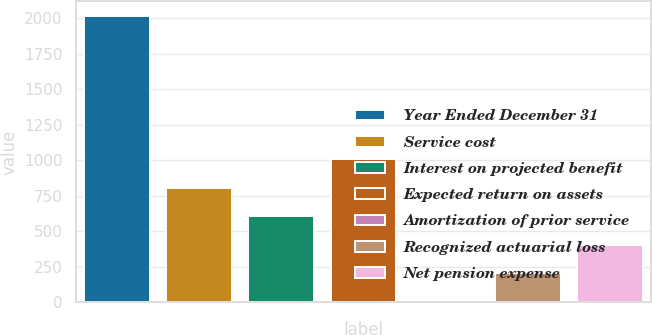Convert chart to OTSL. <chart><loc_0><loc_0><loc_500><loc_500><bar_chart><fcel>Year Ended December 31<fcel>Service cost<fcel>Interest on projected benefit<fcel>Expected return on assets<fcel>Amortization of prior service<fcel>Recognized actuarial loss<fcel>Net pension expense<nl><fcel>2018<fcel>808.04<fcel>606.38<fcel>1009.7<fcel>1.4<fcel>203.06<fcel>404.72<nl></chart> 